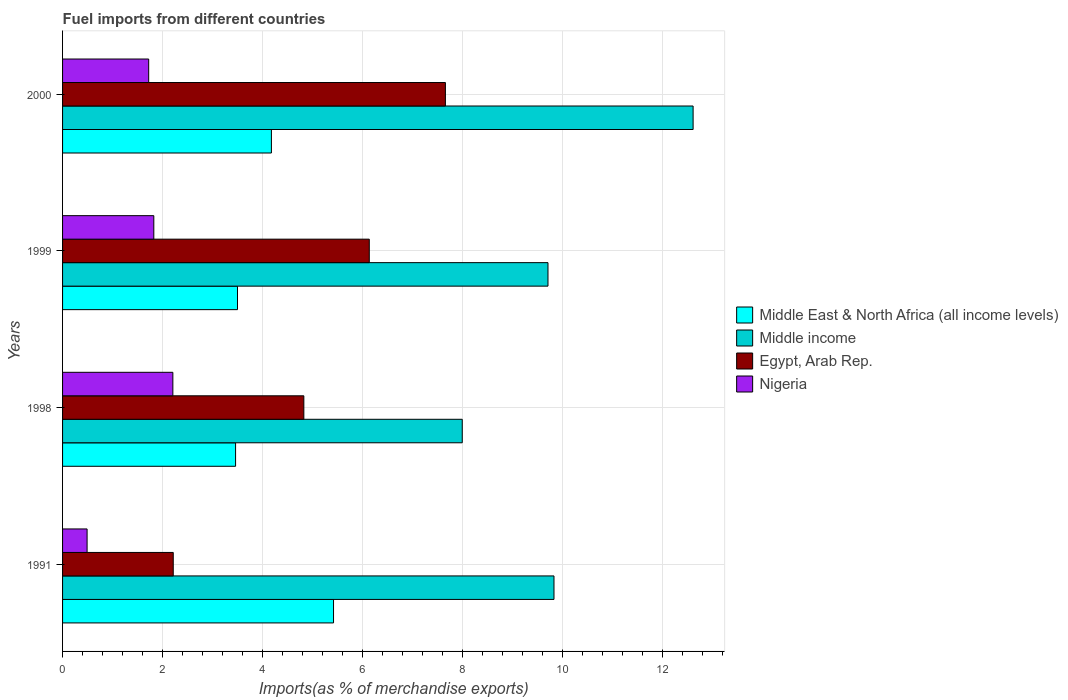How many different coloured bars are there?
Offer a very short reply. 4. How many bars are there on the 1st tick from the bottom?
Give a very brief answer. 4. What is the label of the 2nd group of bars from the top?
Keep it short and to the point. 1999. What is the percentage of imports to different countries in Egypt, Arab Rep. in 1991?
Provide a succinct answer. 2.21. Across all years, what is the maximum percentage of imports to different countries in Middle income?
Provide a short and direct response. 12.6. Across all years, what is the minimum percentage of imports to different countries in Nigeria?
Offer a very short reply. 0.49. In which year was the percentage of imports to different countries in Middle income maximum?
Provide a succinct answer. 2000. What is the total percentage of imports to different countries in Middle income in the graph?
Give a very brief answer. 40.12. What is the difference between the percentage of imports to different countries in Egypt, Arab Rep. in 1998 and that in 1999?
Provide a succinct answer. -1.31. What is the difference between the percentage of imports to different countries in Nigeria in 1991 and the percentage of imports to different countries in Middle East & North Africa (all income levels) in 1999?
Your answer should be compact. -3.01. What is the average percentage of imports to different countries in Middle East & North Africa (all income levels) per year?
Ensure brevity in your answer.  4.14. In the year 1991, what is the difference between the percentage of imports to different countries in Nigeria and percentage of imports to different countries in Middle East & North Africa (all income levels)?
Your answer should be compact. -4.93. In how many years, is the percentage of imports to different countries in Middle income greater than 10.4 %?
Your response must be concise. 1. What is the ratio of the percentage of imports to different countries in Egypt, Arab Rep. in 1991 to that in 1999?
Give a very brief answer. 0.36. What is the difference between the highest and the second highest percentage of imports to different countries in Egypt, Arab Rep.?
Provide a succinct answer. 1.52. What is the difference between the highest and the lowest percentage of imports to different countries in Egypt, Arab Rep.?
Your answer should be compact. 5.44. What does the 2nd bar from the top in 1998 represents?
Provide a succinct answer. Egypt, Arab Rep. What does the 1st bar from the bottom in 1991 represents?
Give a very brief answer. Middle East & North Africa (all income levels). How many bars are there?
Provide a succinct answer. 16. How many years are there in the graph?
Provide a succinct answer. 4. What is the difference between two consecutive major ticks on the X-axis?
Offer a very short reply. 2. Are the values on the major ticks of X-axis written in scientific E-notation?
Provide a short and direct response. No. Does the graph contain any zero values?
Provide a short and direct response. No. Where does the legend appear in the graph?
Your answer should be very brief. Center right. What is the title of the graph?
Keep it short and to the point. Fuel imports from different countries. What is the label or title of the X-axis?
Your answer should be very brief. Imports(as % of merchandise exports). What is the label or title of the Y-axis?
Your answer should be compact. Years. What is the Imports(as % of merchandise exports) of Middle East & North Africa (all income levels) in 1991?
Give a very brief answer. 5.42. What is the Imports(as % of merchandise exports) in Middle income in 1991?
Your answer should be compact. 9.82. What is the Imports(as % of merchandise exports) in Egypt, Arab Rep. in 1991?
Your answer should be very brief. 2.21. What is the Imports(as % of merchandise exports) in Nigeria in 1991?
Your answer should be compact. 0.49. What is the Imports(as % of merchandise exports) in Middle East & North Africa (all income levels) in 1998?
Your answer should be very brief. 3.46. What is the Imports(as % of merchandise exports) of Middle income in 1998?
Offer a terse response. 7.99. What is the Imports(as % of merchandise exports) in Egypt, Arab Rep. in 1998?
Give a very brief answer. 4.82. What is the Imports(as % of merchandise exports) of Nigeria in 1998?
Your answer should be very brief. 2.2. What is the Imports(as % of merchandise exports) in Middle East & North Africa (all income levels) in 1999?
Offer a very short reply. 3.5. What is the Imports(as % of merchandise exports) of Middle income in 1999?
Provide a succinct answer. 9.7. What is the Imports(as % of merchandise exports) of Egypt, Arab Rep. in 1999?
Provide a short and direct response. 6.13. What is the Imports(as % of merchandise exports) in Nigeria in 1999?
Offer a very short reply. 1.82. What is the Imports(as % of merchandise exports) of Middle East & North Africa (all income levels) in 2000?
Provide a short and direct response. 4.17. What is the Imports(as % of merchandise exports) of Middle income in 2000?
Provide a short and direct response. 12.6. What is the Imports(as % of merchandise exports) of Egypt, Arab Rep. in 2000?
Keep it short and to the point. 7.65. What is the Imports(as % of merchandise exports) in Nigeria in 2000?
Offer a very short reply. 1.72. Across all years, what is the maximum Imports(as % of merchandise exports) in Middle East & North Africa (all income levels)?
Make the answer very short. 5.42. Across all years, what is the maximum Imports(as % of merchandise exports) of Middle income?
Your response must be concise. 12.6. Across all years, what is the maximum Imports(as % of merchandise exports) of Egypt, Arab Rep.?
Make the answer very short. 7.65. Across all years, what is the maximum Imports(as % of merchandise exports) of Nigeria?
Make the answer very short. 2.2. Across all years, what is the minimum Imports(as % of merchandise exports) of Middle East & North Africa (all income levels)?
Make the answer very short. 3.46. Across all years, what is the minimum Imports(as % of merchandise exports) in Middle income?
Provide a succinct answer. 7.99. Across all years, what is the minimum Imports(as % of merchandise exports) in Egypt, Arab Rep.?
Your answer should be compact. 2.21. Across all years, what is the minimum Imports(as % of merchandise exports) in Nigeria?
Your answer should be compact. 0.49. What is the total Imports(as % of merchandise exports) in Middle East & North Africa (all income levels) in the graph?
Offer a terse response. 16.55. What is the total Imports(as % of merchandise exports) of Middle income in the graph?
Your answer should be compact. 40.12. What is the total Imports(as % of merchandise exports) in Egypt, Arab Rep. in the graph?
Offer a very short reply. 20.82. What is the total Imports(as % of merchandise exports) of Nigeria in the graph?
Your answer should be compact. 6.24. What is the difference between the Imports(as % of merchandise exports) in Middle East & North Africa (all income levels) in 1991 and that in 1998?
Provide a short and direct response. 1.96. What is the difference between the Imports(as % of merchandise exports) of Middle income in 1991 and that in 1998?
Make the answer very short. 1.83. What is the difference between the Imports(as % of merchandise exports) of Egypt, Arab Rep. in 1991 and that in 1998?
Your answer should be very brief. -2.61. What is the difference between the Imports(as % of merchandise exports) of Nigeria in 1991 and that in 1998?
Provide a short and direct response. -1.71. What is the difference between the Imports(as % of merchandise exports) in Middle East & North Africa (all income levels) in 1991 and that in 1999?
Your response must be concise. 1.92. What is the difference between the Imports(as % of merchandise exports) of Middle income in 1991 and that in 1999?
Your response must be concise. 0.12. What is the difference between the Imports(as % of merchandise exports) in Egypt, Arab Rep. in 1991 and that in 1999?
Offer a terse response. -3.92. What is the difference between the Imports(as % of merchandise exports) in Nigeria in 1991 and that in 1999?
Provide a short and direct response. -1.33. What is the difference between the Imports(as % of merchandise exports) of Middle East & North Africa (all income levels) in 1991 and that in 2000?
Your answer should be very brief. 1.24. What is the difference between the Imports(as % of merchandise exports) of Middle income in 1991 and that in 2000?
Provide a succinct answer. -2.78. What is the difference between the Imports(as % of merchandise exports) of Egypt, Arab Rep. in 1991 and that in 2000?
Provide a succinct answer. -5.44. What is the difference between the Imports(as % of merchandise exports) of Nigeria in 1991 and that in 2000?
Provide a short and direct response. -1.23. What is the difference between the Imports(as % of merchandise exports) of Middle East & North Africa (all income levels) in 1998 and that in 1999?
Your answer should be compact. -0.04. What is the difference between the Imports(as % of merchandise exports) of Middle income in 1998 and that in 1999?
Ensure brevity in your answer.  -1.71. What is the difference between the Imports(as % of merchandise exports) of Egypt, Arab Rep. in 1998 and that in 1999?
Offer a terse response. -1.31. What is the difference between the Imports(as % of merchandise exports) of Nigeria in 1998 and that in 1999?
Ensure brevity in your answer.  0.38. What is the difference between the Imports(as % of merchandise exports) in Middle East & North Africa (all income levels) in 1998 and that in 2000?
Your response must be concise. -0.72. What is the difference between the Imports(as % of merchandise exports) of Middle income in 1998 and that in 2000?
Make the answer very short. -4.61. What is the difference between the Imports(as % of merchandise exports) of Egypt, Arab Rep. in 1998 and that in 2000?
Your answer should be compact. -2.83. What is the difference between the Imports(as % of merchandise exports) of Nigeria in 1998 and that in 2000?
Ensure brevity in your answer.  0.48. What is the difference between the Imports(as % of merchandise exports) of Middle East & North Africa (all income levels) in 1999 and that in 2000?
Provide a succinct answer. -0.68. What is the difference between the Imports(as % of merchandise exports) of Middle income in 1999 and that in 2000?
Give a very brief answer. -2.9. What is the difference between the Imports(as % of merchandise exports) in Egypt, Arab Rep. in 1999 and that in 2000?
Give a very brief answer. -1.52. What is the difference between the Imports(as % of merchandise exports) in Nigeria in 1999 and that in 2000?
Give a very brief answer. 0.1. What is the difference between the Imports(as % of merchandise exports) of Middle East & North Africa (all income levels) in 1991 and the Imports(as % of merchandise exports) of Middle income in 1998?
Your answer should be very brief. -2.57. What is the difference between the Imports(as % of merchandise exports) of Middle East & North Africa (all income levels) in 1991 and the Imports(as % of merchandise exports) of Egypt, Arab Rep. in 1998?
Your response must be concise. 0.59. What is the difference between the Imports(as % of merchandise exports) of Middle East & North Africa (all income levels) in 1991 and the Imports(as % of merchandise exports) of Nigeria in 1998?
Give a very brief answer. 3.21. What is the difference between the Imports(as % of merchandise exports) of Middle income in 1991 and the Imports(as % of merchandise exports) of Egypt, Arab Rep. in 1998?
Your answer should be very brief. 5. What is the difference between the Imports(as % of merchandise exports) in Middle income in 1991 and the Imports(as % of merchandise exports) in Nigeria in 1998?
Ensure brevity in your answer.  7.62. What is the difference between the Imports(as % of merchandise exports) of Egypt, Arab Rep. in 1991 and the Imports(as % of merchandise exports) of Nigeria in 1998?
Ensure brevity in your answer.  0.01. What is the difference between the Imports(as % of merchandise exports) of Middle East & North Africa (all income levels) in 1991 and the Imports(as % of merchandise exports) of Middle income in 1999?
Provide a short and direct response. -4.29. What is the difference between the Imports(as % of merchandise exports) in Middle East & North Africa (all income levels) in 1991 and the Imports(as % of merchandise exports) in Egypt, Arab Rep. in 1999?
Give a very brief answer. -0.71. What is the difference between the Imports(as % of merchandise exports) of Middle East & North Africa (all income levels) in 1991 and the Imports(as % of merchandise exports) of Nigeria in 1999?
Make the answer very short. 3.59. What is the difference between the Imports(as % of merchandise exports) of Middle income in 1991 and the Imports(as % of merchandise exports) of Egypt, Arab Rep. in 1999?
Your answer should be very brief. 3.69. What is the difference between the Imports(as % of merchandise exports) in Middle income in 1991 and the Imports(as % of merchandise exports) in Nigeria in 1999?
Make the answer very short. 8. What is the difference between the Imports(as % of merchandise exports) in Egypt, Arab Rep. in 1991 and the Imports(as % of merchandise exports) in Nigeria in 1999?
Make the answer very short. 0.39. What is the difference between the Imports(as % of merchandise exports) in Middle East & North Africa (all income levels) in 1991 and the Imports(as % of merchandise exports) in Middle income in 2000?
Make the answer very short. -7.19. What is the difference between the Imports(as % of merchandise exports) in Middle East & North Africa (all income levels) in 1991 and the Imports(as % of merchandise exports) in Egypt, Arab Rep. in 2000?
Give a very brief answer. -2.24. What is the difference between the Imports(as % of merchandise exports) in Middle East & North Africa (all income levels) in 1991 and the Imports(as % of merchandise exports) in Nigeria in 2000?
Keep it short and to the point. 3.69. What is the difference between the Imports(as % of merchandise exports) of Middle income in 1991 and the Imports(as % of merchandise exports) of Egypt, Arab Rep. in 2000?
Provide a short and direct response. 2.17. What is the difference between the Imports(as % of merchandise exports) of Middle income in 1991 and the Imports(as % of merchandise exports) of Nigeria in 2000?
Offer a terse response. 8.1. What is the difference between the Imports(as % of merchandise exports) of Egypt, Arab Rep. in 1991 and the Imports(as % of merchandise exports) of Nigeria in 2000?
Offer a very short reply. 0.49. What is the difference between the Imports(as % of merchandise exports) of Middle East & North Africa (all income levels) in 1998 and the Imports(as % of merchandise exports) of Middle income in 1999?
Provide a succinct answer. -6.24. What is the difference between the Imports(as % of merchandise exports) in Middle East & North Africa (all income levels) in 1998 and the Imports(as % of merchandise exports) in Egypt, Arab Rep. in 1999?
Your answer should be very brief. -2.67. What is the difference between the Imports(as % of merchandise exports) of Middle East & North Africa (all income levels) in 1998 and the Imports(as % of merchandise exports) of Nigeria in 1999?
Ensure brevity in your answer.  1.63. What is the difference between the Imports(as % of merchandise exports) of Middle income in 1998 and the Imports(as % of merchandise exports) of Egypt, Arab Rep. in 1999?
Keep it short and to the point. 1.86. What is the difference between the Imports(as % of merchandise exports) of Middle income in 1998 and the Imports(as % of merchandise exports) of Nigeria in 1999?
Provide a succinct answer. 6.16. What is the difference between the Imports(as % of merchandise exports) in Egypt, Arab Rep. in 1998 and the Imports(as % of merchandise exports) in Nigeria in 1999?
Offer a terse response. 3. What is the difference between the Imports(as % of merchandise exports) of Middle East & North Africa (all income levels) in 1998 and the Imports(as % of merchandise exports) of Middle income in 2000?
Make the answer very short. -9.15. What is the difference between the Imports(as % of merchandise exports) in Middle East & North Africa (all income levels) in 1998 and the Imports(as % of merchandise exports) in Egypt, Arab Rep. in 2000?
Provide a succinct answer. -4.19. What is the difference between the Imports(as % of merchandise exports) in Middle East & North Africa (all income levels) in 1998 and the Imports(as % of merchandise exports) in Nigeria in 2000?
Keep it short and to the point. 1.74. What is the difference between the Imports(as % of merchandise exports) in Middle income in 1998 and the Imports(as % of merchandise exports) in Egypt, Arab Rep. in 2000?
Provide a succinct answer. 0.34. What is the difference between the Imports(as % of merchandise exports) of Middle income in 1998 and the Imports(as % of merchandise exports) of Nigeria in 2000?
Your answer should be compact. 6.27. What is the difference between the Imports(as % of merchandise exports) in Egypt, Arab Rep. in 1998 and the Imports(as % of merchandise exports) in Nigeria in 2000?
Keep it short and to the point. 3.1. What is the difference between the Imports(as % of merchandise exports) of Middle East & North Africa (all income levels) in 1999 and the Imports(as % of merchandise exports) of Middle income in 2000?
Offer a terse response. -9.11. What is the difference between the Imports(as % of merchandise exports) in Middle East & North Africa (all income levels) in 1999 and the Imports(as % of merchandise exports) in Egypt, Arab Rep. in 2000?
Your answer should be compact. -4.16. What is the difference between the Imports(as % of merchandise exports) in Middle East & North Africa (all income levels) in 1999 and the Imports(as % of merchandise exports) in Nigeria in 2000?
Make the answer very short. 1.78. What is the difference between the Imports(as % of merchandise exports) in Middle income in 1999 and the Imports(as % of merchandise exports) in Egypt, Arab Rep. in 2000?
Your answer should be compact. 2.05. What is the difference between the Imports(as % of merchandise exports) in Middle income in 1999 and the Imports(as % of merchandise exports) in Nigeria in 2000?
Give a very brief answer. 7.98. What is the difference between the Imports(as % of merchandise exports) in Egypt, Arab Rep. in 1999 and the Imports(as % of merchandise exports) in Nigeria in 2000?
Your answer should be very brief. 4.41. What is the average Imports(as % of merchandise exports) in Middle East & North Africa (all income levels) per year?
Provide a succinct answer. 4.14. What is the average Imports(as % of merchandise exports) in Middle income per year?
Your answer should be very brief. 10.03. What is the average Imports(as % of merchandise exports) of Egypt, Arab Rep. per year?
Give a very brief answer. 5.2. What is the average Imports(as % of merchandise exports) in Nigeria per year?
Provide a succinct answer. 1.56. In the year 1991, what is the difference between the Imports(as % of merchandise exports) of Middle East & North Africa (all income levels) and Imports(as % of merchandise exports) of Middle income?
Your answer should be compact. -4.41. In the year 1991, what is the difference between the Imports(as % of merchandise exports) in Middle East & North Africa (all income levels) and Imports(as % of merchandise exports) in Egypt, Arab Rep.?
Your answer should be compact. 3.2. In the year 1991, what is the difference between the Imports(as % of merchandise exports) in Middle East & North Africa (all income levels) and Imports(as % of merchandise exports) in Nigeria?
Provide a succinct answer. 4.93. In the year 1991, what is the difference between the Imports(as % of merchandise exports) in Middle income and Imports(as % of merchandise exports) in Egypt, Arab Rep.?
Your answer should be compact. 7.61. In the year 1991, what is the difference between the Imports(as % of merchandise exports) in Middle income and Imports(as % of merchandise exports) in Nigeria?
Ensure brevity in your answer.  9.33. In the year 1991, what is the difference between the Imports(as % of merchandise exports) in Egypt, Arab Rep. and Imports(as % of merchandise exports) in Nigeria?
Give a very brief answer. 1.72. In the year 1998, what is the difference between the Imports(as % of merchandise exports) of Middle East & North Africa (all income levels) and Imports(as % of merchandise exports) of Middle income?
Your answer should be very brief. -4.53. In the year 1998, what is the difference between the Imports(as % of merchandise exports) of Middle East & North Africa (all income levels) and Imports(as % of merchandise exports) of Egypt, Arab Rep.?
Make the answer very short. -1.36. In the year 1998, what is the difference between the Imports(as % of merchandise exports) of Middle East & North Africa (all income levels) and Imports(as % of merchandise exports) of Nigeria?
Give a very brief answer. 1.25. In the year 1998, what is the difference between the Imports(as % of merchandise exports) in Middle income and Imports(as % of merchandise exports) in Egypt, Arab Rep.?
Provide a succinct answer. 3.17. In the year 1998, what is the difference between the Imports(as % of merchandise exports) of Middle income and Imports(as % of merchandise exports) of Nigeria?
Offer a very short reply. 5.78. In the year 1998, what is the difference between the Imports(as % of merchandise exports) of Egypt, Arab Rep. and Imports(as % of merchandise exports) of Nigeria?
Your answer should be compact. 2.62. In the year 1999, what is the difference between the Imports(as % of merchandise exports) of Middle East & North Africa (all income levels) and Imports(as % of merchandise exports) of Middle income?
Your response must be concise. -6.21. In the year 1999, what is the difference between the Imports(as % of merchandise exports) in Middle East & North Africa (all income levels) and Imports(as % of merchandise exports) in Egypt, Arab Rep.?
Provide a short and direct response. -2.63. In the year 1999, what is the difference between the Imports(as % of merchandise exports) in Middle East & North Africa (all income levels) and Imports(as % of merchandise exports) in Nigeria?
Keep it short and to the point. 1.67. In the year 1999, what is the difference between the Imports(as % of merchandise exports) of Middle income and Imports(as % of merchandise exports) of Egypt, Arab Rep.?
Make the answer very short. 3.57. In the year 1999, what is the difference between the Imports(as % of merchandise exports) of Middle income and Imports(as % of merchandise exports) of Nigeria?
Your answer should be very brief. 7.88. In the year 1999, what is the difference between the Imports(as % of merchandise exports) in Egypt, Arab Rep. and Imports(as % of merchandise exports) in Nigeria?
Offer a terse response. 4.31. In the year 2000, what is the difference between the Imports(as % of merchandise exports) in Middle East & North Africa (all income levels) and Imports(as % of merchandise exports) in Middle income?
Offer a terse response. -8.43. In the year 2000, what is the difference between the Imports(as % of merchandise exports) in Middle East & North Africa (all income levels) and Imports(as % of merchandise exports) in Egypt, Arab Rep.?
Give a very brief answer. -3.48. In the year 2000, what is the difference between the Imports(as % of merchandise exports) in Middle East & North Africa (all income levels) and Imports(as % of merchandise exports) in Nigeria?
Keep it short and to the point. 2.45. In the year 2000, what is the difference between the Imports(as % of merchandise exports) of Middle income and Imports(as % of merchandise exports) of Egypt, Arab Rep.?
Make the answer very short. 4.95. In the year 2000, what is the difference between the Imports(as % of merchandise exports) in Middle income and Imports(as % of merchandise exports) in Nigeria?
Provide a short and direct response. 10.88. In the year 2000, what is the difference between the Imports(as % of merchandise exports) in Egypt, Arab Rep. and Imports(as % of merchandise exports) in Nigeria?
Give a very brief answer. 5.93. What is the ratio of the Imports(as % of merchandise exports) in Middle East & North Africa (all income levels) in 1991 to that in 1998?
Offer a very short reply. 1.57. What is the ratio of the Imports(as % of merchandise exports) of Middle income in 1991 to that in 1998?
Your answer should be compact. 1.23. What is the ratio of the Imports(as % of merchandise exports) in Egypt, Arab Rep. in 1991 to that in 1998?
Provide a short and direct response. 0.46. What is the ratio of the Imports(as % of merchandise exports) in Nigeria in 1991 to that in 1998?
Make the answer very short. 0.22. What is the ratio of the Imports(as % of merchandise exports) of Middle East & North Africa (all income levels) in 1991 to that in 1999?
Keep it short and to the point. 1.55. What is the ratio of the Imports(as % of merchandise exports) of Middle income in 1991 to that in 1999?
Ensure brevity in your answer.  1.01. What is the ratio of the Imports(as % of merchandise exports) of Egypt, Arab Rep. in 1991 to that in 1999?
Offer a very short reply. 0.36. What is the ratio of the Imports(as % of merchandise exports) of Nigeria in 1991 to that in 1999?
Ensure brevity in your answer.  0.27. What is the ratio of the Imports(as % of merchandise exports) of Middle East & North Africa (all income levels) in 1991 to that in 2000?
Make the answer very short. 1.3. What is the ratio of the Imports(as % of merchandise exports) in Middle income in 1991 to that in 2000?
Your answer should be compact. 0.78. What is the ratio of the Imports(as % of merchandise exports) in Egypt, Arab Rep. in 1991 to that in 2000?
Your answer should be very brief. 0.29. What is the ratio of the Imports(as % of merchandise exports) in Nigeria in 1991 to that in 2000?
Keep it short and to the point. 0.28. What is the ratio of the Imports(as % of merchandise exports) in Middle income in 1998 to that in 1999?
Your answer should be compact. 0.82. What is the ratio of the Imports(as % of merchandise exports) of Egypt, Arab Rep. in 1998 to that in 1999?
Offer a terse response. 0.79. What is the ratio of the Imports(as % of merchandise exports) in Nigeria in 1998 to that in 1999?
Make the answer very short. 1.21. What is the ratio of the Imports(as % of merchandise exports) in Middle East & North Africa (all income levels) in 1998 to that in 2000?
Your answer should be compact. 0.83. What is the ratio of the Imports(as % of merchandise exports) in Middle income in 1998 to that in 2000?
Provide a succinct answer. 0.63. What is the ratio of the Imports(as % of merchandise exports) of Egypt, Arab Rep. in 1998 to that in 2000?
Your answer should be compact. 0.63. What is the ratio of the Imports(as % of merchandise exports) of Nigeria in 1998 to that in 2000?
Your answer should be very brief. 1.28. What is the ratio of the Imports(as % of merchandise exports) of Middle East & North Africa (all income levels) in 1999 to that in 2000?
Provide a short and direct response. 0.84. What is the ratio of the Imports(as % of merchandise exports) of Middle income in 1999 to that in 2000?
Your response must be concise. 0.77. What is the ratio of the Imports(as % of merchandise exports) of Egypt, Arab Rep. in 1999 to that in 2000?
Keep it short and to the point. 0.8. What is the ratio of the Imports(as % of merchandise exports) of Nigeria in 1999 to that in 2000?
Provide a short and direct response. 1.06. What is the difference between the highest and the second highest Imports(as % of merchandise exports) of Middle East & North Africa (all income levels)?
Offer a terse response. 1.24. What is the difference between the highest and the second highest Imports(as % of merchandise exports) in Middle income?
Ensure brevity in your answer.  2.78. What is the difference between the highest and the second highest Imports(as % of merchandise exports) of Egypt, Arab Rep.?
Make the answer very short. 1.52. What is the difference between the highest and the second highest Imports(as % of merchandise exports) in Nigeria?
Provide a short and direct response. 0.38. What is the difference between the highest and the lowest Imports(as % of merchandise exports) of Middle East & North Africa (all income levels)?
Make the answer very short. 1.96. What is the difference between the highest and the lowest Imports(as % of merchandise exports) in Middle income?
Provide a short and direct response. 4.61. What is the difference between the highest and the lowest Imports(as % of merchandise exports) of Egypt, Arab Rep.?
Provide a succinct answer. 5.44. What is the difference between the highest and the lowest Imports(as % of merchandise exports) in Nigeria?
Ensure brevity in your answer.  1.71. 